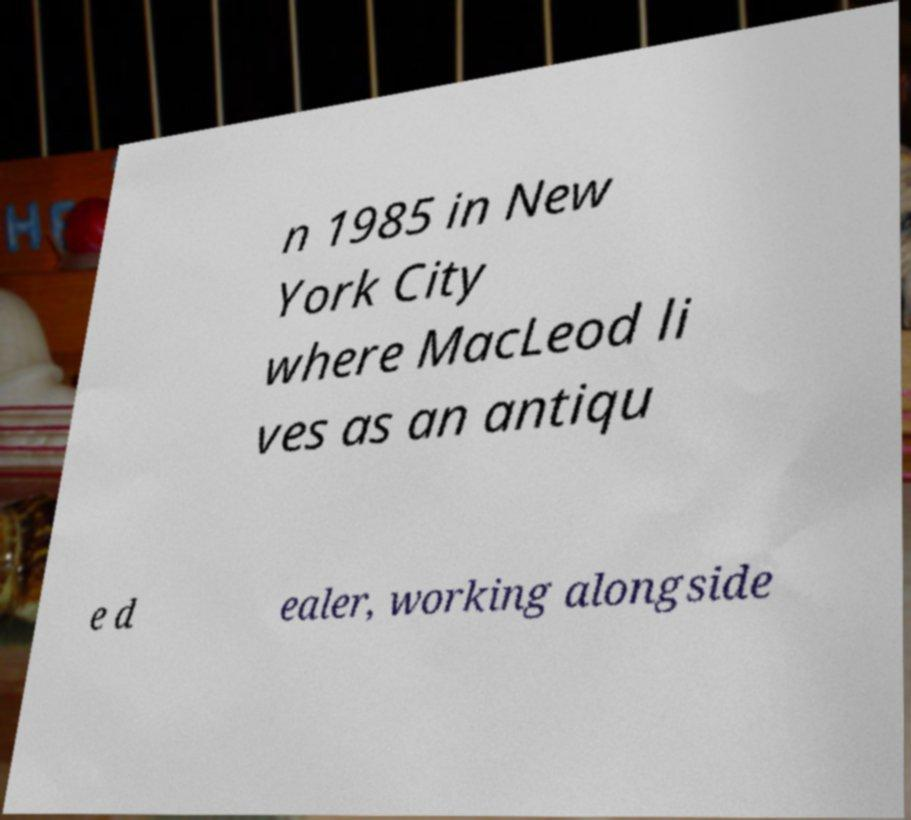Could you assist in decoding the text presented in this image and type it out clearly? n 1985 in New York City where MacLeod li ves as an antiqu e d ealer, working alongside 